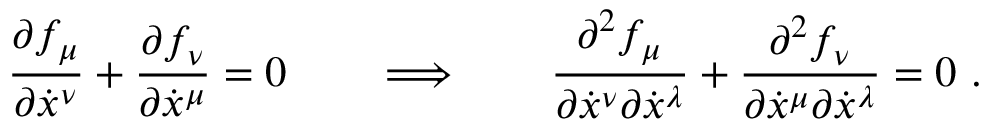<formula> <loc_0><loc_0><loc_500><loc_500>\frac { \partial f _ { \mu } } { \partial \dot { x } ^ { \nu } } + \frac { \partial f _ { \nu } } { \partial \dot { x } ^ { \mu } } = 0 \quad \Longrightarrow \quad \frac { \partial ^ { 2 } f _ { \mu } } { \partial \dot { x } ^ { \nu } \partial \dot { x } ^ { \lambda } } + \frac { \partial ^ { 2 } f _ { \nu } } { \partial \dot { x } ^ { \mu } \partial \dot { x } ^ { \lambda } } = 0 \ .</formula> 